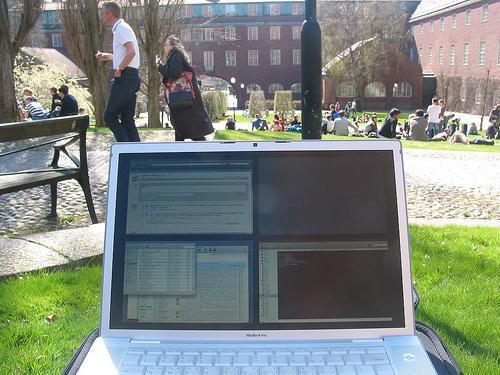How many computers are in the photo?
Give a very brief answer. 1. 